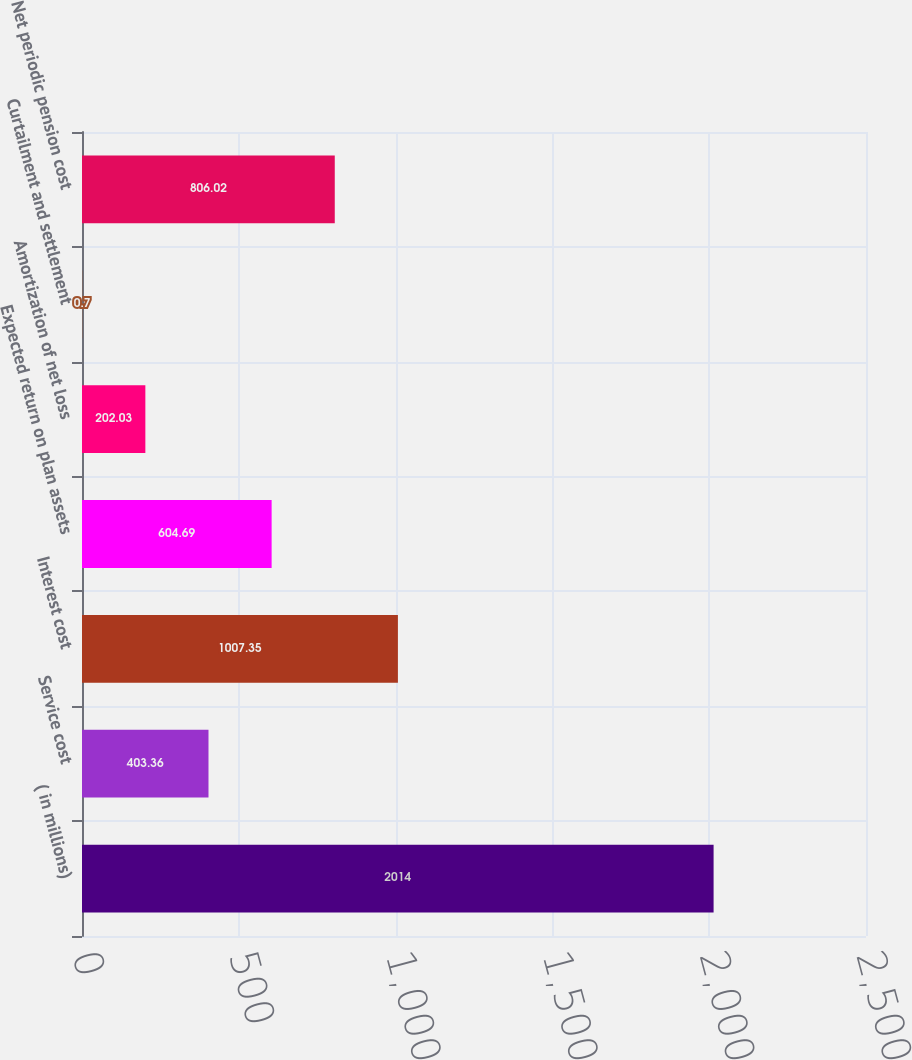<chart> <loc_0><loc_0><loc_500><loc_500><bar_chart><fcel>( in millions)<fcel>Service cost<fcel>Interest cost<fcel>Expected return on plan assets<fcel>Amortization of net loss<fcel>Curtailment and settlement<fcel>Net periodic pension cost<nl><fcel>2014<fcel>403.36<fcel>1007.35<fcel>604.69<fcel>202.03<fcel>0.7<fcel>806.02<nl></chart> 